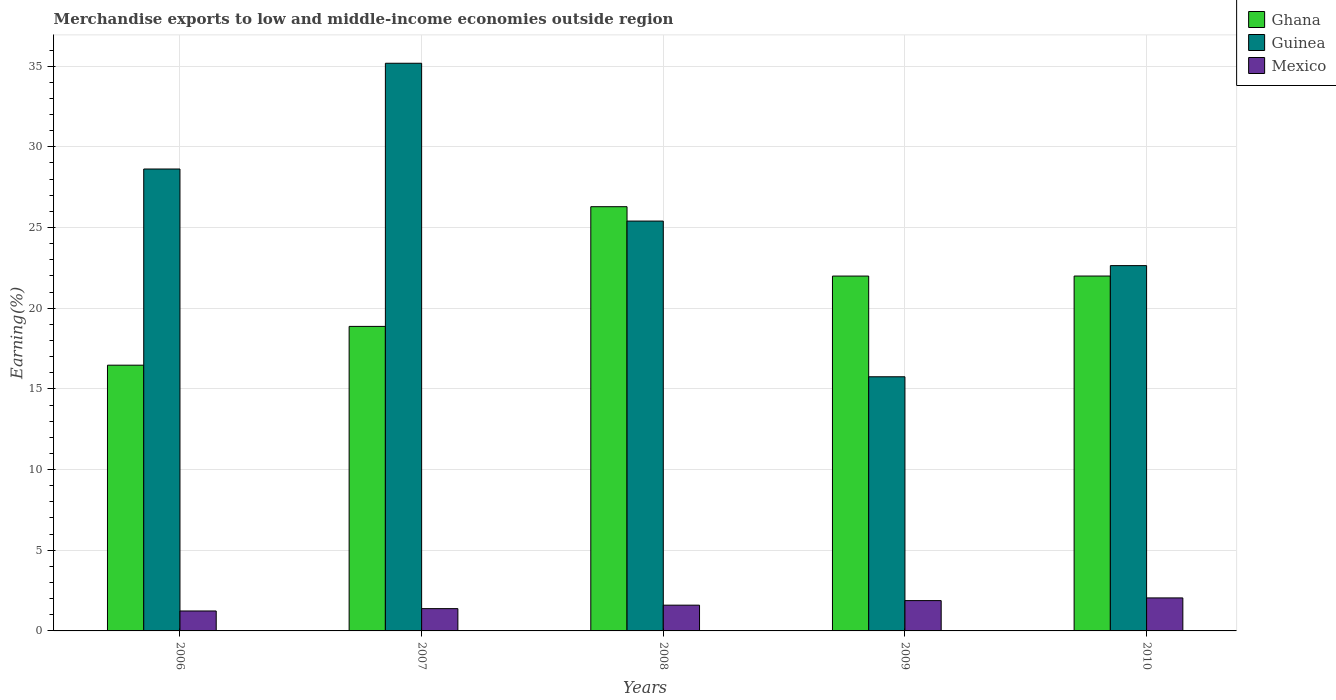How many bars are there on the 3rd tick from the left?
Your response must be concise. 3. How many bars are there on the 3rd tick from the right?
Provide a succinct answer. 3. What is the percentage of amount earned from merchandise exports in Ghana in 2010?
Keep it short and to the point. 21.99. Across all years, what is the maximum percentage of amount earned from merchandise exports in Mexico?
Provide a short and direct response. 2.05. Across all years, what is the minimum percentage of amount earned from merchandise exports in Mexico?
Your response must be concise. 1.24. In which year was the percentage of amount earned from merchandise exports in Guinea maximum?
Make the answer very short. 2007. In which year was the percentage of amount earned from merchandise exports in Mexico minimum?
Give a very brief answer. 2006. What is the total percentage of amount earned from merchandise exports in Ghana in the graph?
Offer a terse response. 105.62. What is the difference between the percentage of amount earned from merchandise exports in Ghana in 2007 and that in 2008?
Your answer should be very brief. -7.42. What is the difference between the percentage of amount earned from merchandise exports in Mexico in 2007 and the percentage of amount earned from merchandise exports in Guinea in 2010?
Your answer should be compact. -21.26. What is the average percentage of amount earned from merchandise exports in Ghana per year?
Provide a succinct answer. 21.12. In the year 2008, what is the difference between the percentage of amount earned from merchandise exports in Ghana and percentage of amount earned from merchandise exports in Guinea?
Make the answer very short. 0.89. In how many years, is the percentage of amount earned from merchandise exports in Ghana greater than 30 %?
Your answer should be very brief. 0. What is the ratio of the percentage of amount earned from merchandise exports in Ghana in 2007 to that in 2010?
Your response must be concise. 0.86. Is the percentage of amount earned from merchandise exports in Guinea in 2007 less than that in 2010?
Keep it short and to the point. No. What is the difference between the highest and the second highest percentage of amount earned from merchandise exports in Ghana?
Your answer should be compact. 4.3. What is the difference between the highest and the lowest percentage of amount earned from merchandise exports in Ghana?
Offer a very short reply. 9.82. In how many years, is the percentage of amount earned from merchandise exports in Mexico greater than the average percentage of amount earned from merchandise exports in Mexico taken over all years?
Your response must be concise. 2. What does the 1st bar from the right in 2010 represents?
Offer a very short reply. Mexico. Are all the bars in the graph horizontal?
Your response must be concise. No. Are the values on the major ticks of Y-axis written in scientific E-notation?
Offer a very short reply. No. Does the graph contain any zero values?
Keep it short and to the point. No. Where does the legend appear in the graph?
Your answer should be very brief. Top right. How many legend labels are there?
Your answer should be compact. 3. How are the legend labels stacked?
Your answer should be very brief. Vertical. What is the title of the graph?
Give a very brief answer. Merchandise exports to low and middle-income economies outside region. What is the label or title of the X-axis?
Give a very brief answer. Years. What is the label or title of the Y-axis?
Your response must be concise. Earning(%). What is the Earning(%) in Ghana in 2006?
Ensure brevity in your answer.  16.47. What is the Earning(%) in Guinea in 2006?
Provide a succinct answer. 28.63. What is the Earning(%) of Mexico in 2006?
Offer a terse response. 1.24. What is the Earning(%) of Ghana in 2007?
Ensure brevity in your answer.  18.87. What is the Earning(%) in Guinea in 2007?
Keep it short and to the point. 35.18. What is the Earning(%) in Mexico in 2007?
Offer a terse response. 1.38. What is the Earning(%) in Ghana in 2008?
Your answer should be compact. 26.29. What is the Earning(%) of Guinea in 2008?
Your answer should be compact. 25.4. What is the Earning(%) of Mexico in 2008?
Make the answer very short. 1.6. What is the Earning(%) of Ghana in 2009?
Your answer should be compact. 21.99. What is the Earning(%) in Guinea in 2009?
Provide a succinct answer. 15.75. What is the Earning(%) in Mexico in 2009?
Ensure brevity in your answer.  1.88. What is the Earning(%) of Ghana in 2010?
Offer a terse response. 21.99. What is the Earning(%) of Guinea in 2010?
Provide a short and direct response. 22.64. What is the Earning(%) in Mexico in 2010?
Your answer should be compact. 2.05. Across all years, what is the maximum Earning(%) of Ghana?
Offer a very short reply. 26.29. Across all years, what is the maximum Earning(%) of Guinea?
Your response must be concise. 35.18. Across all years, what is the maximum Earning(%) of Mexico?
Give a very brief answer. 2.05. Across all years, what is the minimum Earning(%) of Ghana?
Your answer should be compact. 16.47. Across all years, what is the minimum Earning(%) of Guinea?
Ensure brevity in your answer.  15.75. Across all years, what is the minimum Earning(%) of Mexico?
Provide a succinct answer. 1.24. What is the total Earning(%) of Ghana in the graph?
Offer a very short reply. 105.62. What is the total Earning(%) in Guinea in the graph?
Ensure brevity in your answer.  127.6. What is the total Earning(%) of Mexico in the graph?
Keep it short and to the point. 8.14. What is the difference between the Earning(%) in Ghana in 2006 and that in 2007?
Your response must be concise. -2.4. What is the difference between the Earning(%) in Guinea in 2006 and that in 2007?
Your response must be concise. -6.55. What is the difference between the Earning(%) of Mexico in 2006 and that in 2007?
Provide a succinct answer. -0.14. What is the difference between the Earning(%) in Ghana in 2006 and that in 2008?
Provide a succinct answer. -9.82. What is the difference between the Earning(%) of Guinea in 2006 and that in 2008?
Keep it short and to the point. 3.23. What is the difference between the Earning(%) of Mexico in 2006 and that in 2008?
Your answer should be very brief. -0.36. What is the difference between the Earning(%) in Ghana in 2006 and that in 2009?
Ensure brevity in your answer.  -5.52. What is the difference between the Earning(%) in Guinea in 2006 and that in 2009?
Offer a terse response. 12.88. What is the difference between the Earning(%) of Mexico in 2006 and that in 2009?
Your answer should be very brief. -0.64. What is the difference between the Earning(%) in Ghana in 2006 and that in 2010?
Keep it short and to the point. -5.52. What is the difference between the Earning(%) of Guinea in 2006 and that in 2010?
Keep it short and to the point. 5.99. What is the difference between the Earning(%) in Mexico in 2006 and that in 2010?
Your answer should be compact. -0.81. What is the difference between the Earning(%) in Ghana in 2007 and that in 2008?
Make the answer very short. -7.42. What is the difference between the Earning(%) of Guinea in 2007 and that in 2008?
Keep it short and to the point. 9.78. What is the difference between the Earning(%) in Mexico in 2007 and that in 2008?
Ensure brevity in your answer.  -0.22. What is the difference between the Earning(%) of Ghana in 2007 and that in 2009?
Your answer should be compact. -3.12. What is the difference between the Earning(%) of Guinea in 2007 and that in 2009?
Ensure brevity in your answer.  19.43. What is the difference between the Earning(%) of Mexico in 2007 and that in 2009?
Make the answer very short. -0.5. What is the difference between the Earning(%) of Ghana in 2007 and that in 2010?
Provide a short and direct response. -3.12. What is the difference between the Earning(%) in Guinea in 2007 and that in 2010?
Make the answer very short. 12.54. What is the difference between the Earning(%) in Mexico in 2007 and that in 2010?
Your answer should be very brief. -0.66. What is the difference between the Earning(%) in Ghana in 2008 and that in 2009?
Your response must be concise. 4.3. What is the difference between the Earning(%) in Guinea in 2008 and that in 2009?
Give a very brief answer. 9.65. What is the difference between the Earning(%) in Mexico in 2008 and that in 2009?
Offer a terse response. -0.28. What is the difference between the Earning(%) in Ghana in 2008 and that in 2010?
Provide a succinct answer. 4.3. What is the difference between the Earning(%) of Guinea in 2008 and that in 2010?
Keep it short and to the point. 2.76. What is the difference between the Earning(%) of Mexico in 2008 and that in 2010?
Ensure brevity in your answer.  -0.45. What is the difference between the Earning(%) of Ghana in 2009 and that in 2010?
Provide a short and direct response. -0. What is the difference between the Earning(%) in Guinea in 2009 and that in 2010?
Your answer should be compact. -6.89. What is the difference between the Earning(%) of Mexico in 2009 and that in 2010?
Offer a very short reply. -0.17. What is the difference between the Earning(%) in Ghana in 2006 and the Earning(%) in Guinea in 2007?
Offer a very short reply. -18.71. What is the difference between the Earning(%) in Ghana in 2006 and the Earning(%) in Mexico in 2007?
Make the answer very short. 15.09. What is the difference between the Earning(%) in Guinea in 2006 and the Earning(%) in Mexico in 2007?
Offer a very short reply. 27.25. What is the difference between the Earning(%) in Ghana in 2006 and the Earning(%) in Guinea in 2008?
Keep it short and to the point. -8.93. What is the difference between the Earning(%) in Ghana in 2006 and the Earning(%) in Mexico in 2008?
Provide a succinct answer. 14.87. What is the difference between the Earning(%) of Guinea in 2006 and the Earning(%) of Mexico in 2008?
Keep it short and to the point. 27.03. What is the difference between the Earning(%) in Ghana in 2006 and the Earning(%) in Guinea in 2009?
Ensure brevity in your answer.  0.72. What is the difference between the Earning(%) in Ghana in 2006 and the Earning(%) in Mexico in 2009?
Keep it short and to the point. 14.59. What is the difference between the Earning(%) in Guinea in 2006 and the Earning(%) in Mexico in 2009?
Give a very brief answer. 26.75. What is the difference between the Earning(%) in Ghana in 2006 and the Earning(%) in Guinea in 2010?
Offer a terse response. -6.17. What is the difference between the Earning(%) in Ghana in 2006 and the Earning(%) in Mexico in 2010?
Offer a very short reply. 14.42. What is the difference between the Earning(%) of Guinea in 2006 and the Earning(%) of Mexico in 2010?
Your answer should be very brief. 26.58. What is the difference between the Earning(%) of Ghana in 2007 and the Earning(%) of Guinea in 2008?
Your answer should be compact. -6.53. What is the difference between the Earning(%) in Ghana in 2007 and the Earning(%) in Mexico in 2008?
Make the answer very short. 17.28. What is the difference between the Earning(%) in Guinea in 2007 and the Earning(%) in Mexico in 2008?
Offer a terse response. 33.58. What is the difference between the Earning(%) in Ghana in 2007 and the Earning(%) in Guinea in 2009?
Ensure brevity in your answer.  3.12. What is the difference between the Earning(%) of Ghana in 2007 and the Earning(%) of Mexico in 2009?
Offer a terse response. 16.99. What is the difference between the Earning(%) in Guinea in 2007 and the Earning(%) in Mexico in 2009?
Give a very brief answer. 33.3. What is the difference between the Earning(%) of Ghana in 2007 and the Earning(%) of Guinea in 2010?
Give a very brief answer. -3.77. What is the difference between the Earning(%) in Ghana in 2007 and the Earning(%) in Mexico in 2010?
Your response must be concise. 16.83. What is the difference between the Earning(%) of Guinea in 2007 and the Earning(%) of Mexico in 2010?
Offer a terse response. 33.13. What is the difference between the Earning(%) of Ghana in 2008 and the Earning(%) of Guinea in 2009?
Give a very brief answer. 10.54. What is the difference between the Earning(%) in Ghana in 2008 and the Earning(%) in Mexico in 2009?
Provide a short and direct response. 24.41. What is the difference between the Earning(%) of Guinea in 2008 and the Earning(%) of Mexico in 2009?
Provide a short and direct response. 23.52. What is the difference between the Earning(%) in Ghana in 2008 and the Earning(%) in Guinea in 2010?
Give a very brief answer. 3.65. What is the difference between the Earning(%) in Ghana in 2008 and the Earning(%) in Mexico in 2010?
Make the answer very short. 24.25. What is the difference between the Earning(%) of Guinea in 2008 and the Earning(%) of Mexico in 2010?
Provide a succinct answer. 23.35. What is the difference between the Earning(%) of Ghana in 2009 and the Earning(%) of Guinea in 2010?
Make the answer very short. -0.65. What is the difference between the Earning(%) of Ghana in 2009 and the Earning(%) of Mexico in 2010?
Provide a short and direct response. 19.95. What is the difference between the Earning(%) of Guinea in 2009 and the Earning(%) of Mexico in 2010?
Your answer should be very brief. 13.71. What is the average Earning(%) in Ghana per year?
Provide a succinct answer. 21.12. What is the average Earning(%) of Guinea per year?
Ensure brevity in your answer.  25.52. What is the average Earning(%) of Mexico per year?
Your response must be concise. 1.63. In the year 2006, what is the difference between the Earning(%) in Ghana and Earning(%) in Guinea?
Provide a succinct answer. -12.16. In the year 2006, what is the difference between the Earning(%) in Ghana and Earning(%) in Mexico?
Provide a short and direct response. 15.23. In the year 2006, what is the difference between the Earning(%) in Guinea and Earning(%) in Mexico?
Keep it short and to the point. 27.39. In the year 2007, what is the difference between the Earning(%) of Ghana and Earning(%) of Guinea?
Your answer should be compact. -16.31. In the year 2007, what is the difference between the Earning(%) of Ghana and Earning(%) of Mexico?
Your answer should be very brief. 17.49. In the year 2007, what is the difference between the Earning(%) of Guinea and Earning(%) of Mexico?
Provide a short and direct response. 33.8. In the year 2008, what is the difference between the Earning(%) in Ghana and Earning(%) in Guinea?
Give a very brief answer. 0.89. In the year 2008, what is the difference between the Earning(%) in Ghana and Earning(%) in Mexico?
Give a very brief answer. 24.69. In the year 2008, what is the difference between the Earning(%) of Guinea and Earning(%) of Mexico?
Offer a terse response. 23.8. In the year 2009, what is the difference between the Earning(%) in Ghana and Earning(%) in Guinea?
Ensure brevity in your answer.  6.24. In the year 2009, what is the difference between the Earning(%) of Ghana and Earning(%) of Mexico?
Provide a succinct answer. 20.11. In the year 2009, what is the difference between the Earning(%) of Guinea and Earning(%) of Mexico?
Offer a terse response. 13.87. In the year 2010, what is the difference between the Earning(%) of Ghana and Earning(%) of Guinea?
Make the answer very short. -0.65. In the year 2010, what is the difference between the Earning(%) in Ghana and Earning(%) in Mexico?
Make the answer very short. 19.95. In the year 2010, what is the difference between the Earning(%) in Guinea and Earning(%) in Mexico?
Provide a succinct answer. 20.59. What is the ratio of the Earning(%) in Ghana in 2006 to that in 2007?
Your answer should be very brief. 0.87. What is the ratio of the Earning(%) of Guinea in 2006 to that in 2007?
Keep it short and to the point. 0.81. What is the ratio of the Earning(%) in Mexico in 2006 to that in 2007?
Keep it short and to the point. 0.9. What is the ratio of the Earning(%) in Ghana in 2006 to that in 2008?
Your answer should be very brief. 0.63. What is the ratio of the Earning(%) of Guinea in 2006 to that in 2008?
Offer a very short reply. 1.13. What is the ratio of the Earning(%) in Mexico in 2006 to that in 2008?
Your answer should be compact. 0.77. What is the ratio of the Earning(%) of Ghana in 2006 to that in 2009?
Provide a short and direct response. 0.75. What is the ratio of the Earning(%) in Guinea in 2006 to that in 2009?
Provide a short and direct response. 1.82. What is the ratio of the Earning(%) in Mexico in 2006 to that in 2009?
Keep it short and to the point. 0.66. What is the ratio of the Earning(%) in Ghana in 2006 to that in 2010?
Your response must be concise. 0.75. What is the ratio of the Earning(%) in Guinea in 2006 to that in 2010?
Provide a short and direct response. 1.26. What is the ratio of the Earning(%) of Mexico in 2006 to that in 2010?
Offer a very short reply. 0.6. What is the ratio of the Earning(%) in Ghana in 2007 to that in 2008?
Provide a short and direct response. 0.72. What is the ratio of the Earning(%) in Guinea in 2007 to that in 2008?
Provide a short and direct response. 1.39. What is the ratio of the Earning(%) in Mexico in 2007 to that in 2008?
Offer a terse response. 0.86. What is the ratio of the Earning(%) in Ghana in 2007 to that in 2009?
Ensure brevity in your answer.  0.86. What is the ratio of the Earning(%) of Guinea in 2007 to that in 2009?
Keep it short and to the point. 2.23. What is the ratio of the Earning(%) in Mexico in 2007 to that in 2009?
Your answer should be compact. 0.74. What is the ratio of the Earning(%) of Ghana in 2007 to that in 2010?
Your answer should be very brief. 0.86. What is the ratio of the Earning(%) of Guinea in 2007 to that in 2010?
Give a very brief answer. 1.55. What is the ratio of the Earning(%) of Mexico in 2007 to that in 2010?
Keep it short and to the point. 0.68. What is the ratio of the Earning(%) of Ghana in 2008 to that in 2009?
Ensure brevity in your answer.  1.2. What is the ratio of the Earning(%) of Guinea in 2008 to that in 2009?
Your answer should be compact. 1.61. What is the ratio of the Earning(%) in Mexico in 2008 to that in 2009?
Offer a terse response. 0.85. What is the ratio of the Earning(%) in Ghana in 2008 to that in 2010?
Make the answer very short. 1.2. What is the ratio of the Earning(%) in Guinea in 2008 to that in 2010?
Your response must be concise. 1.12. What is the ratio of the Earning(%) of Mexico in 2008 to that in 2010?
Your answer should be very brief. 0.78. What is the ratio of the Earning(%) of Ghana in 2009 to that in 2010?
Your answer should be very brief. 1. What is the ratio of the Earning(%) in Guinea in 2009 to that in 2010?
Offer a very short reply. 0.7. What is the ratio of the Earning(%) of Mexico in 2009 to that in 2010?
Provide a short and direct response. 0.92. What is the difference between the highest and the second highest Earning(%) of Ghana?
Make the answer very short. 4.3. What is the difference between the highest and the second highest Earning(%) of Guinea?
Offer a very short reply. 6.55. What is the difference between the highest and the second highest Earning(%) of Mexico?
Offer a very short reply. 0.17. What is the difference between the highest and the lowest Earning(%) of Ghana?
Offer a terse response. 9.82. What is the difference between the highest and the lowest Earning(%) in Guinea?
Keep it short and to the point. 19.43. What is the difference between the highest and the lowest Earning(%) of Mexico?
Offer a terse response. 0.81. 